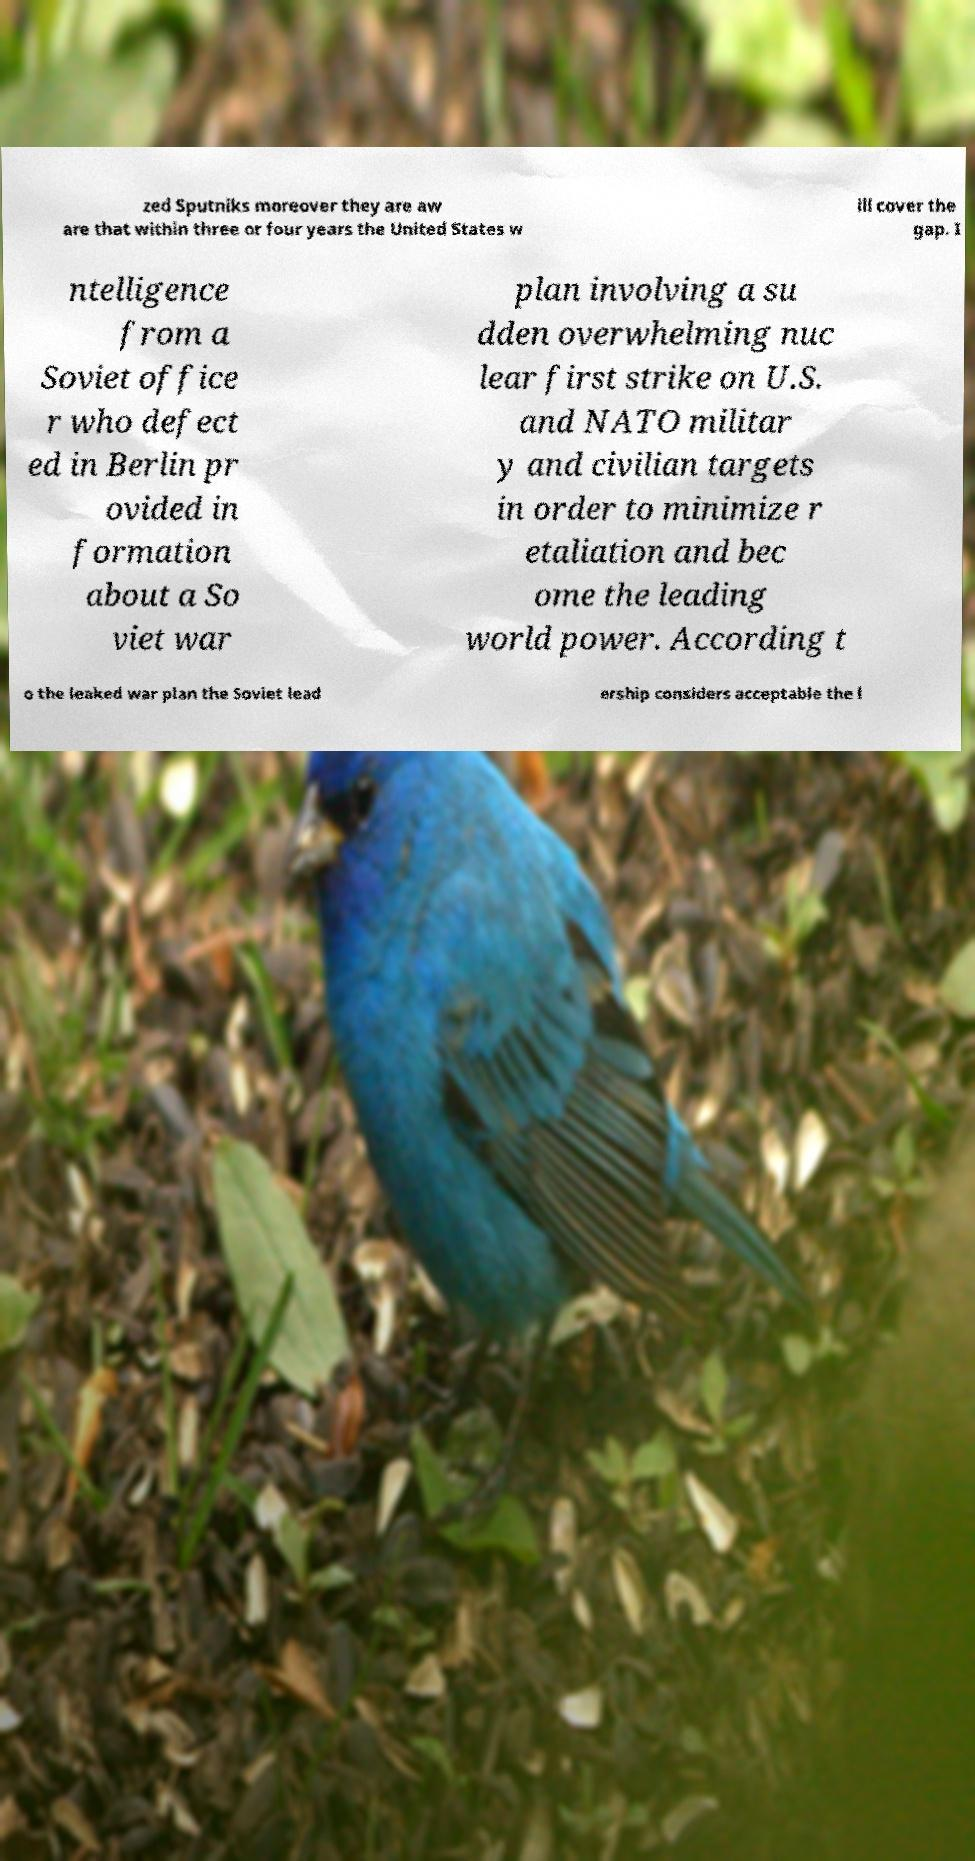Could you assist in decoding the text presented in this image and type it out clearly? zed Sputniks moreover they are aw are that within three or four years the United States w ill cover the gap. I ntelligence from a Soviet office r who defect ed in Berlin pr ovided in formation about a So viet war plan involving a su dden overwhelming nuc lear first strike on U.S. and NATO militar y and civilian targets in order to minimize r etaliation and bec ome the leading world power. According t o the leaked war plan the Soviet lead ership considers acceptable the l 